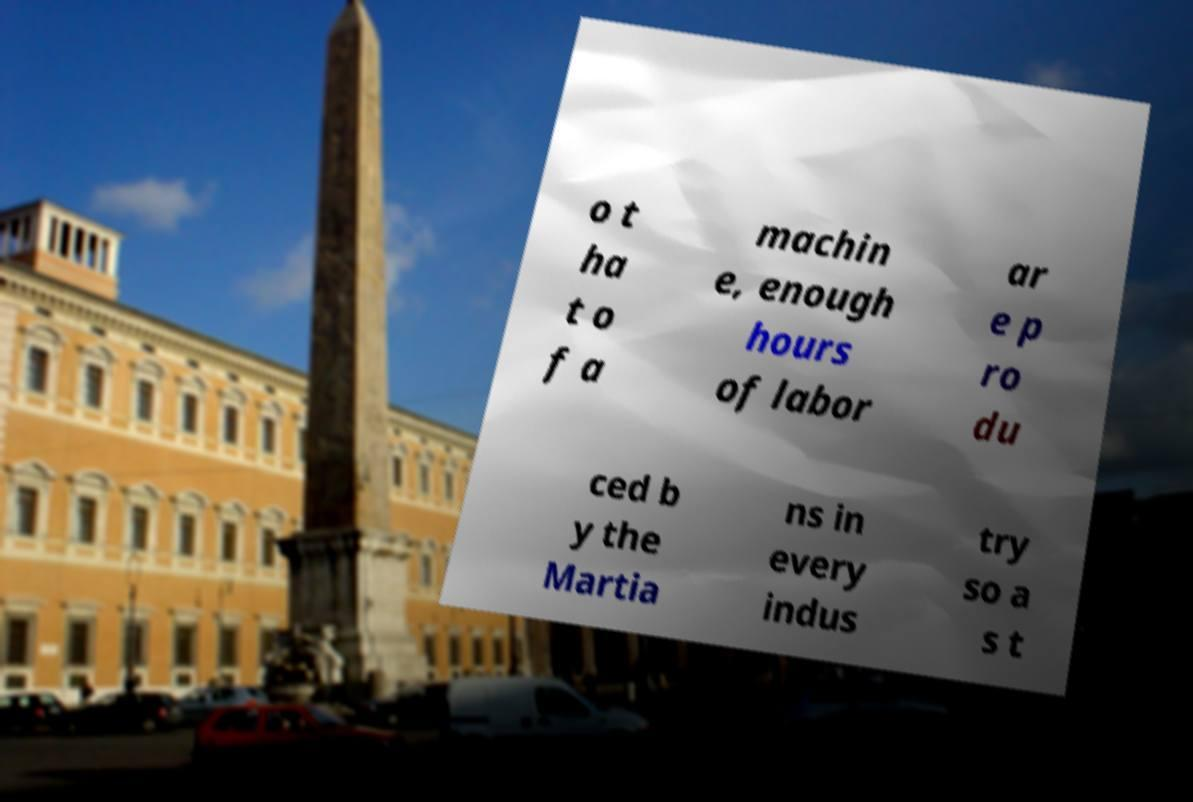What messages or text are displayed in this image? I need them in a readable, typed format. o t ha t o f a machin e, enough hours of labor ar e p ro du ced b y the Martia ns in every indus try so a s t 